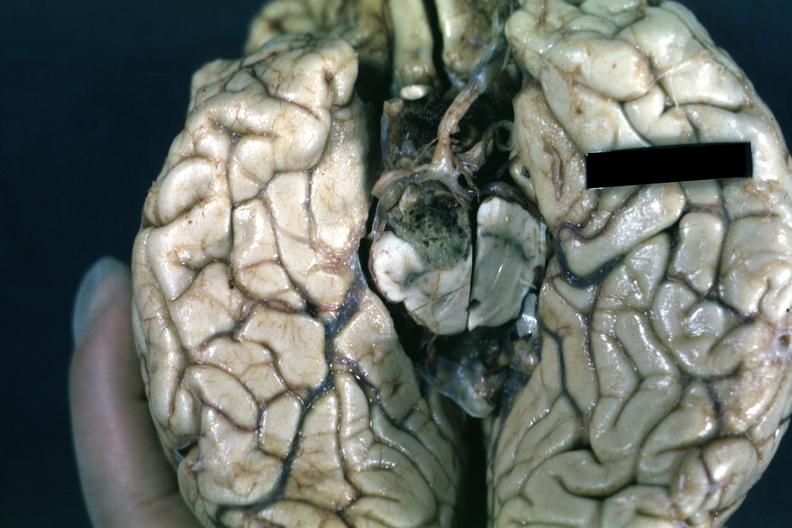s liver present?
Answer the question using a single word or phrase. No 